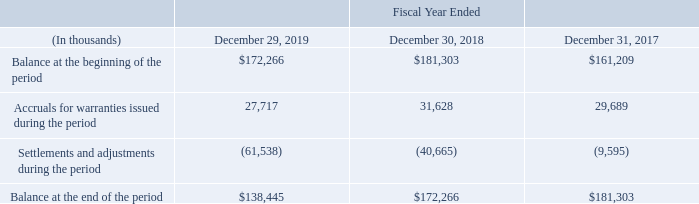Product Warranties
The following table summarizes accrued warranty activities for fiscal 2019, 2018 and 2017:
In some cases, we may offer customers the option to purchase extended warranties to ensure protection beyond the standard warranty period. In those circumstances, the warranty is considered a distinct service and we account for the extended warranty as a performance obligation and allocate a portion of the transaction price to that performance obligation. More frequently, customers do not purchase a warranty separately. In those situations, we account for the warranty as an assurance-type warranty, which provides customers with assurance that the product complies with agreed-upon specifications, and this does not represent a separate performance obligation. Such warranties are recorded separately as liabilities and presented within ‘‘accrued liabilities’’ and ‘‘other long-term liabilities’’ on our consolidated balance sheets (see Note 5. Balance Sheet Components).
In what situation is warranty accounted as an assurance-type warranty? Customers do not purchase a warranty separately. What does an assurance-type warranty provide? Provides customers with assurance that the product complies with agreed-upon specifications. Which year has the highest balance at the end of the period? $181,303 > $172,266 > $138,445
Answer: 2017. What is the percentage change in accruals for warranties issued from 2018 to 2019?
Answer scale should be: percent. (27,717 - 31,628)/31,628 
Answer: -12.37. In which years is accrued warranty activities recorded for?  2019, 2018, 2017. What would be the change in balance at the beginning of the period from 2017 to 2018?
Answer scale should be: thousand. $181,303 - $161,209 
Answer: 20094. 